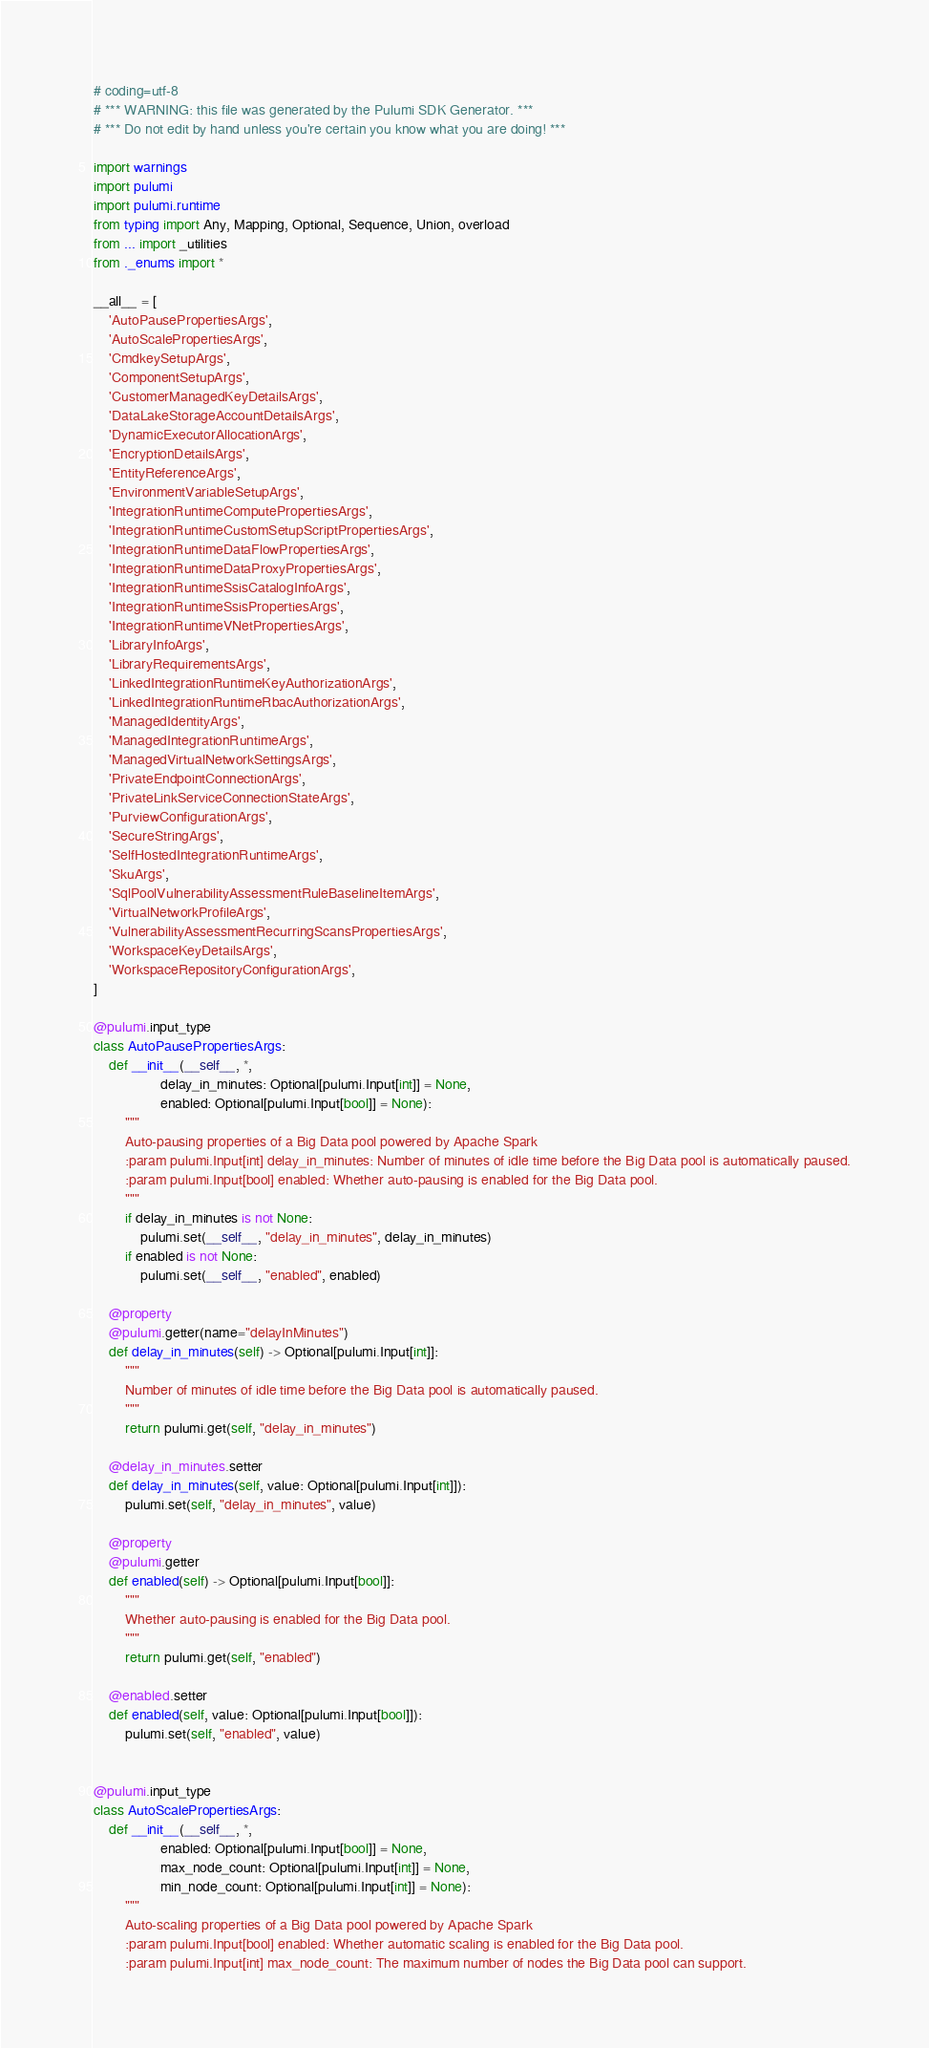<code> <loc_0><loc_0><loc_500><loc_500><_Python_># coding=utf-8
# *** WARNING: this file was generated by the Pulumi SDK Generator. ***
# *** Do not edit by hand unless you're certain you know what you are doing! ***

import warnings
import pulumi
import pulumi.runtime
from typing import Any, Mapping, Optional, Sequence, Union, overload
from ... import _utilities
from ._enums import *

__all__ = [
    'AutoPausePropertiesArgs',
    'AutoScalePropertiesArgs',
    'CmdkeySetupArgs',
    'ComponentSetupArgs',
    'CustomerManagedKeyDetailsArgs',
    'DataLakeStorageAccountDetailsArgs',
    'DynamicExecutorAllocationArgs',
    'EncryptionDetailsArgs',
    'EntityReferenceArgs',
    'EnvironmentVariableSetupArgs',
    'IntegrationRuntimeComputePropertiesArgs',
    'IntegrationRuntimeCustomSetupScriptPropertiesArgs',
    'IntegrationRuntimeDataFlowPropertiesArgs',
    'IntegrationRuntimeDataProxyPropertiesArgs',
    'IntegrationRuntimeSsisCatalogInfoArgs',
    'IntegrationRuntimeSsisPropertiesArgs',
    'IntegrationRuntimeVNetPropertiesArgs',
    'LibraryInfoArgs',
    'LibraryRequirementsArgs',
    'LinkedIntegrationRuntimeKeyAuthorizationArgs',
    'LinkedIntegrationRuntimeRbacAuthorizationArgs',
    'ManagedIdentityArgs',
    'ManagedIntegrationRuntimeArgs',
    'ManagedVirtualNetworkSettingsArgs',
    'PrivateEndpointConnectionArgs',
    'PrivateLinkServiceConnectionStateArgs',
    'PurviewConfigurationArgs',
    'SecureStringArgs',
    'SelfHostedIntegrationRuntimeArgs',
    'SkuArgs',
    'SqlPoolVulnerabilityAssessmentRuleBaselineItemArgs',
    'VirtualNetworkProfileArgs',
    'VulnerabilityAssessmentRecurringScansPropertiesArgs',
    'WorkspaceKeyDetailsArgs',
    'WorkspaceRepositoryConfigurationArgs',
]

@pulumi.input_type
class AutoPausePropertiesArgs:
    def __init__(__self__, *,
                 delay_in_minutes: Optional[pulumi.Input[int]] = None,
                 enabled: Optional[pulumi.Input[bool]] = None):
        """
        Auto-pausing properties of a Big Data pool powered by Apache Spark
        :param pulumi.Input[int] delay_in_minutes: Number of minutes of idle time before the Big Data pool is automatically paused.
        :param pulumi.Input[bool] enabled: Whether auto-pausing is enabled for the Big Data pool.
        """
        if delay_in_minutes is not None:
            pulumi.set(__self__, "delay_in_minutes", delay_in_minutes)
        if enabled is not None:
            pulumi.set(__self__, "enabled", enabled)

    @property
    @pulumi.getter(name="delayInMinutes")
    def delay_in_minutes(self) -> Optional[pulumi.Input[int]]:
        """
        Number of minutes of idle time before the Big Data pool is automatically paused.
        """
        return pulumi.get(self, "delay_in_minutes")

    @delay_in_minutes.setter
    def delay_in_minutes(self, value: Optional[pulumi.Input[int]]):
        pulumi.set(self, "delay_in_minutes", value)

    @property
    @pulumi.getter
    def enabled(self) -> Optional[pulumi.Input[bool]]:
        """
        Whether auto-pausing is enabled for the Big Data pool.
        """
        return pulumi.get(self, "enabled")

    @enabled.setter
    def enabled(self, value: Optional[pulumi.Input[bool]]):
        pulumi.set(self, "enabled", value)


@pulumi.input_type
class AutoScalePropertiesArgs:
    def __init__(__self__, *,
                 enabled: Optional[pulumi.Input[bool]] = None,
                 max_node_count: Optional[pulumi.Input[int]] = None,
                 min_node_count: Optional[pulumi.Input[int]] = None):
        """
        Auto-scaling properties of a Big Data pool powered by Apache Spark
        :param pulumi.Input[bool] enabled: Whether automatic scaling is enabled for the Big Data pool.
        :param pulumi.Input[int] max_node_count: The maximum number of nodes the Big Data pool can support.</code> 